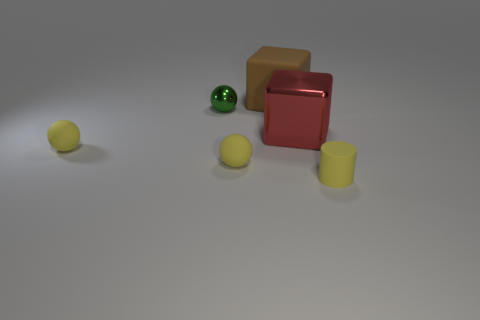Add 2 red blocks. How many objects exist? 8 Subtract all cylinders. How many objects are left? 5 Subtract all large brown shiny balls. Subtract all brown objects. How many objects are left? 5 Add 6 tiny green metallic things. How many tiny green metallic things are left? 7 Add 6 big red matte blocks. How many big red matte blocks exist? 6 Subtract 0 blue cubes. How many objects are left? 6 